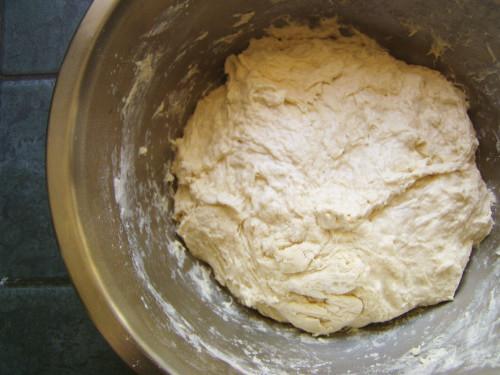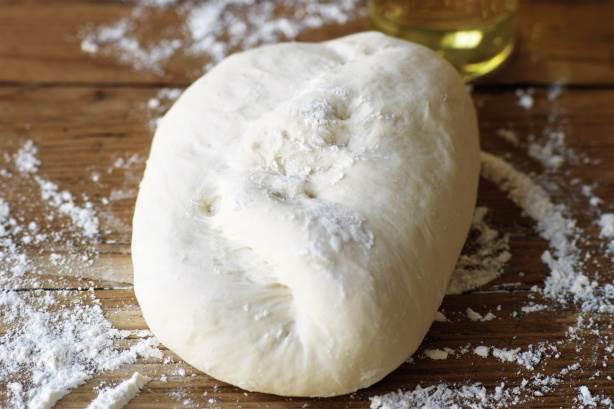The first image is the image on the left, the second image is the image on the right. For the images displayed, is the sentence "There is a utensil in some dough." factually correct? Answer yes or no. No. The first image is the image on the left, the second image is the image on the right. Considering the images on both sides, is "In at least one image there is a utenical in a silver mixing bowl." valid? Answer yes or no. No. 